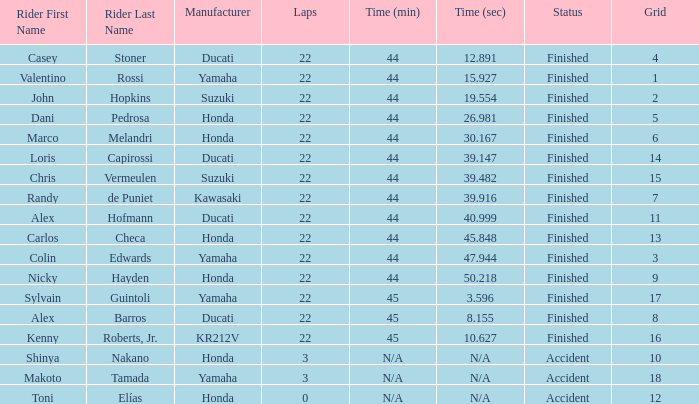What was the average amount of laps for competitors with a grid that was more than 11 and a Time/Retired of +28.108? None. 